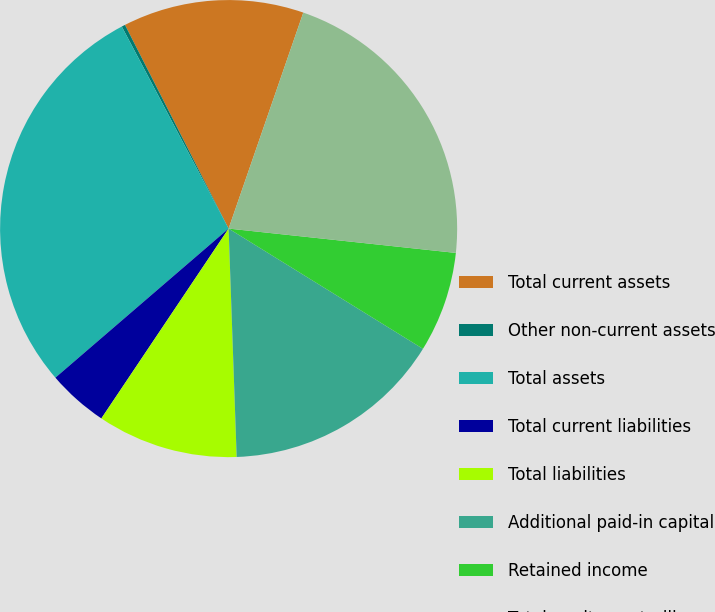Convert chart to OTSL. <chart><loc_0><loc_0><loc_500><loc_500><pie_chart><fcel>Total current assets<fcel>Other non-current assets<fcel>Total assets<fcel>Total current liabilities<fcel>Total liabilities<fcel>Additional paid-in capital<fcel>Retained income<fcel>Total equity-controlling<nl><fcel>12.79%<fcel>0.25%<fcel>28.57%<fcel>4.29%<fcel>9.96%<fcel>15.62%<fcel>7.12%<fcel>21.4%<nl></chart> 